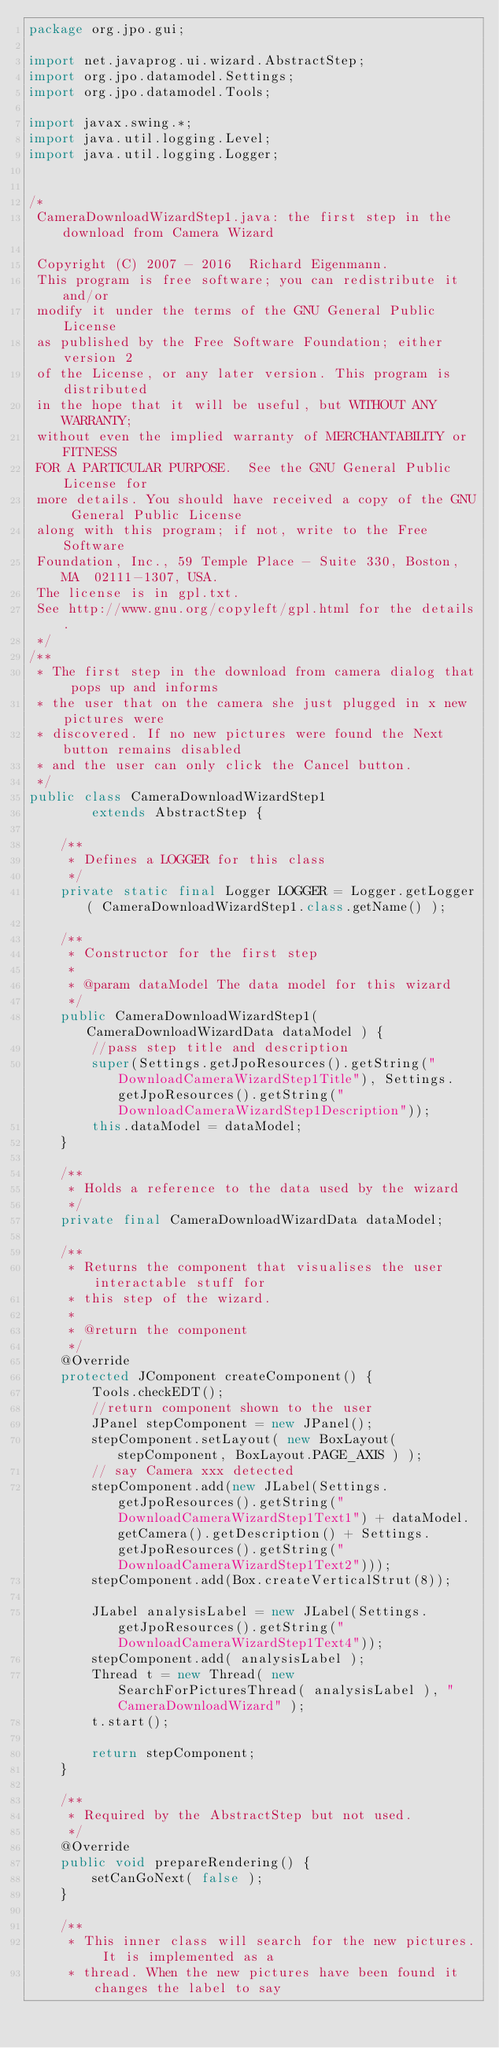<code> <loc_0><loc_0><loc_500><loc_500><_Java_>package org.jpo.gui;

import net.javaprog.ui.wizard.AbstractStep;
import org.jpo.datamodel.Settings;
import org.jpo.datamodel.Tools;

import javax.swing.*;
import java.util.logging.Level;
import java.util.logging.Logger;


/*
 CameraDownloadWizardStep1.java: the first step in the download from Camera Wizard

 Copyright (C) 2007 - 2016  Richard Eigenmann.
 This program is free software; you can redistribute it and/or
 modify it under the terms of the GNU General Public License
 as published by the Free Software Foundation; either version 2
 of the License, or any later version. This program is distributed
 in the hope that it will be useful, but WITHOUT ANY WARRANTY;
 without even the implied warranty of MERCHANTABILITY or FITNESS
 FOR A PARTICULAR PURPOSE.  See the GNU General Public License for
 more details. You should have received a copy of the GNU General Public License
 along with this program; if not, write to the Free Software
 Foundation, Inc., 59 Temple Place - Suite 330, Boston, MA  02111-1307, USA.
 The license is in gpl.txt.
 See http://www.gnu.org/copyleft/gpl.html for the details.
 */
/**
 * The first step in the download from camera dialog that pops up and informs
 * the user that on the camera she just plugged in x new pictures were
 * discovered. If no new pictures were found the Next button remains disabled
 * and the user can only click the Cancel button.
 */
public class CameraDownloadWizardStep1
        extends AbstractStep {

    /**
     * Defines a LOGGER for this class
     */
    private static final Logger LOGGER = Logger.getLogger( CameraDownloadWizardStep1.class.getName() );

    /**
     * Constructor for the first step
     *
     * @param dataModel The data model for this wizard
     */
    public CameraDownloadWizardStep1( CameraDownloadWizardData dataModel ) {
        //pass step title and description
        super(Settings.getJpoResources().getString("DownloadCameraWizardStep1Title"), Settings.getJpoResources().getString("DownloadCameraWizardStep1Description"));
        this.dataModel = dataModel;
    }

    /**
     * Holds a reference to the data used by the wizard
     */
    private final CameraDownloadWizardData dataModel;

    /**
     * Returns the component that visualises the user interactable stuff for
     * this step of the wizard.
     *
     * @return the component
     */
    @Override
    protected JComponent createComponent() {
        Tools.checkEDT();
        //return component shown to the user
        JPanel stepComponent = new JPanel();
        stepComponent.setLayout( new BoxLayout( stepComponent, BoxLayout.PAGE_AXIS ) );
        // say Camera xxx detected
        stepComponent.add(new JLabel(Settings.getJpoResources().getString("DownloadCameraWizardStep1Text1") + dataModel.getCamera().getDescription() + Settings.getJpoResources().getString("DownloadCameraWizardStep1Text2")));
        stepComponent.add(Box.createVerticalStrut(8));

        JLabel analysisLabel = new JLabel(Settings.getJpoResources().getString("DownloadCameraWizardStep1Text4"));
        stepComponent.add( analysisLabel );
        Thread t = new Thread( new SearchForPicturesThread( analysisLabel ), "CameraDownloadWizard" );
        t.start();

        return stepComponent;
    }

    /**
     * Required by the AbstractStep but not used.
     */
    @Override
    public void prepareRendering() {
        setCanGoNext( false );
    }

    /**
     * This inner class will search for the new pictures. It is implemented as a
     * thread. When the new pictures have been found it changes the label to say</code> 